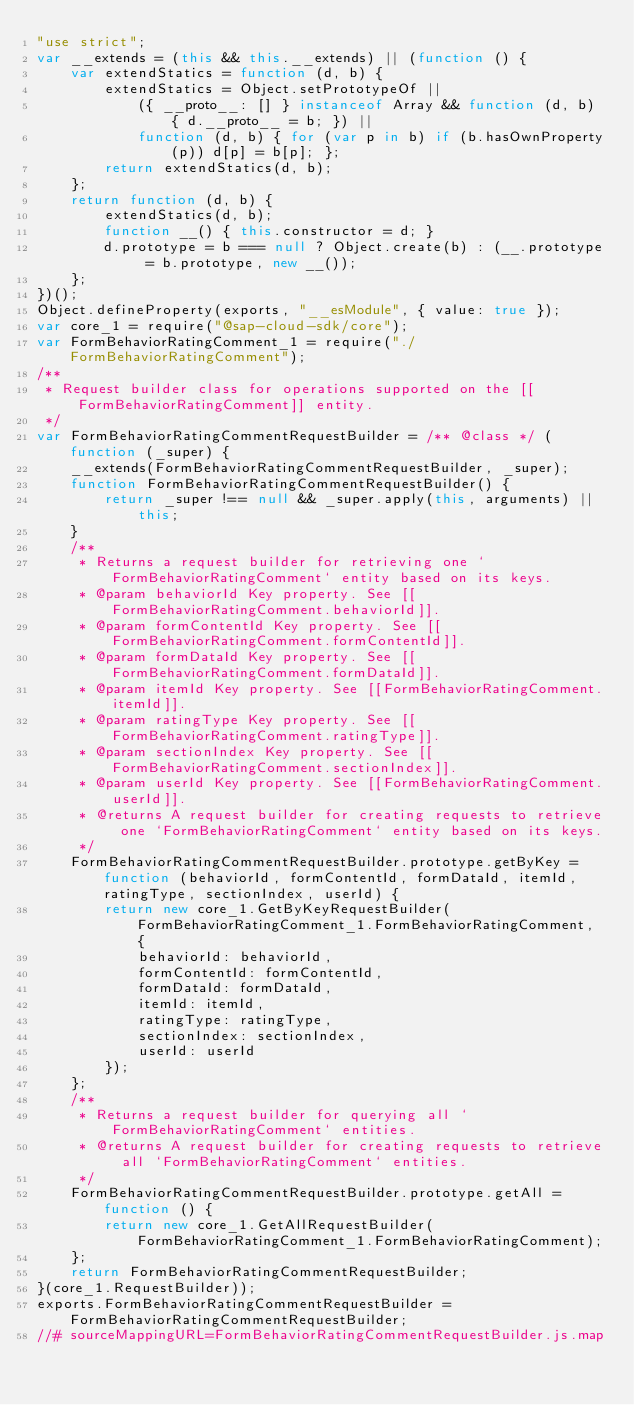Convert code to text. <code><loc_0><loc_0><loc_500><loc_500><_JavaScript_>"use strict";
var __extends = (this && this.__extends) || (function () {
    var extendStatics = function (d, b) {
        extendStatics = Object.setPrototypeOf ||
            ({ __proto__: [] } instanceof Array && function (d, b) { d.__proto__ = b; }) ||
            function (d, b) { for (var p in b) if (b.hasOwnProperty(p)) d[p] = b[p]; };
        return extendStatics(d, b);
    };
    return function (d, b) {
        extendStatics(d, b);
        function __() { this.constructor = d; }
        d.prototype = b === null ? Object.create(b) : (__.prototype = b.prototype, new __());
    };
})();
Object.defineProperty(exports, "__esModule", { value: true });
var core_1 = require("@sap-cloud-sdk/core");
var FormBehaviorRatingComment_1 = require("./FormBehaviorRatingComment");
/**
 * Request builder class for operations supported on the [[FormBehaviorRatingComment]] entity.
 */
var FormBehaviorRatingCommentRequestBuilder = /** @class */ (function (_super) {
    __extends(FormBehaviorRatingCommentRequestBuilder, _super);
    function FormBehaviorRatingCommentRequestBuilder() {
        return _super !== null && _super.apply(this, arguments) || this;
    }
    /**
     * Returns a request builder for retrieving one `FormBehaviorRatingComment` entity based on its keys.
     * @param behaviorId Key property. See [[FormBehaviorRatingComment.behaviorId]].
     * @param formContentId Key property. See [[FormBehaviorRatingComment.formContentId]].
     * @param formDataId Key property. See [[FormBehaviorRatingComment.formDataId]].
     * @param itemId Key property. See [[FormBehaviorRatingComment.itemId]].
     * @param ratingType Key property. See [[FormBehaviorRatingComment.ratingType]].
     * @param sectionIndex Key property. See [[FormBehaviorRatingComment.sectionIndex]].
     * @param userId Key property. See [[FormBehaviorRatingComment.userId]].
     * @returns A request builder for creating requests to retrieve one `FormBehaviorRatingComment` entity based on its keys.
     */
    FormBehaviorRatingCommentRequestBuilder.prototype.getByKey = function (behaviorId, formContentId, formDataId, itemId, ratingType, sectionIndex, userId) {
        return new core_1.GetByKeyRequestBuilder(FormBehaviorRatingComment_1.FormBehaviorRatingComment, {
            behaviorId: behaviorId,
            formContentId: formContentId,
            formDataId: formDataId,
            itemId: itemId,
            ratingType: ratingType,
            sectionIndex: sectionIndex,
            userId: userId
        });
    };
    /**
     * Returns a request builder for querying all `FormBehaviorRatingComment` entities.
     * @returns A request builder for creating requests to retrieve all `FormBehaviorRatingComment` entities.
     */
    FormBehaviorRatingCommentRequestBuilder.prototype.getAll = function () {
        return new core_1.GetAllRequestBuilder(FormBehaviorRatingComment_1.FormBehaviorRatingComment);
    };
    return FormBehaviorRatingCommentRequestBuilder;
}(core_1.RequestBuilder));
exports.FormBehaviorRatingCommentRequestBuilder = FormBehaviorRatingCommentRequestBuilder;
//# sourceMappingURL=FormBehaviorRatingCommentRequestBuilder.js.map</code> 